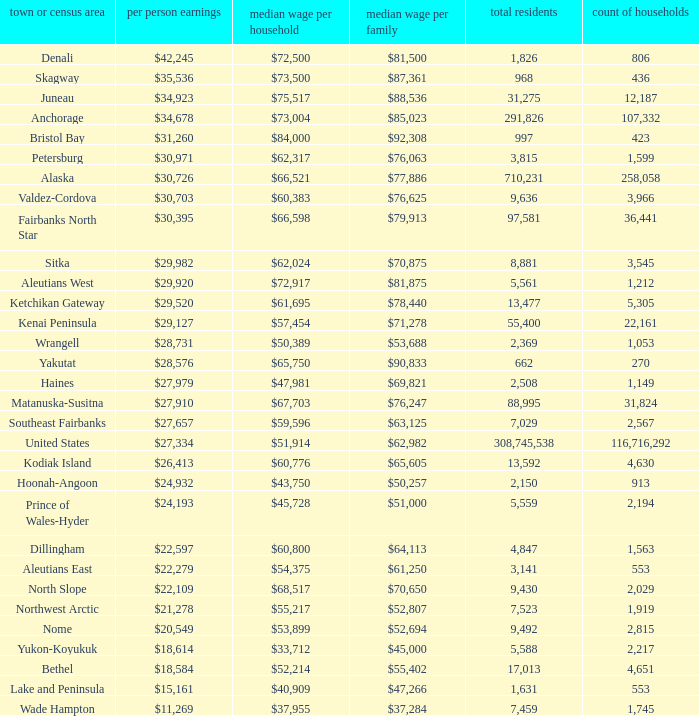What is the population of the area with a median family income of $71,278? 1.0. 